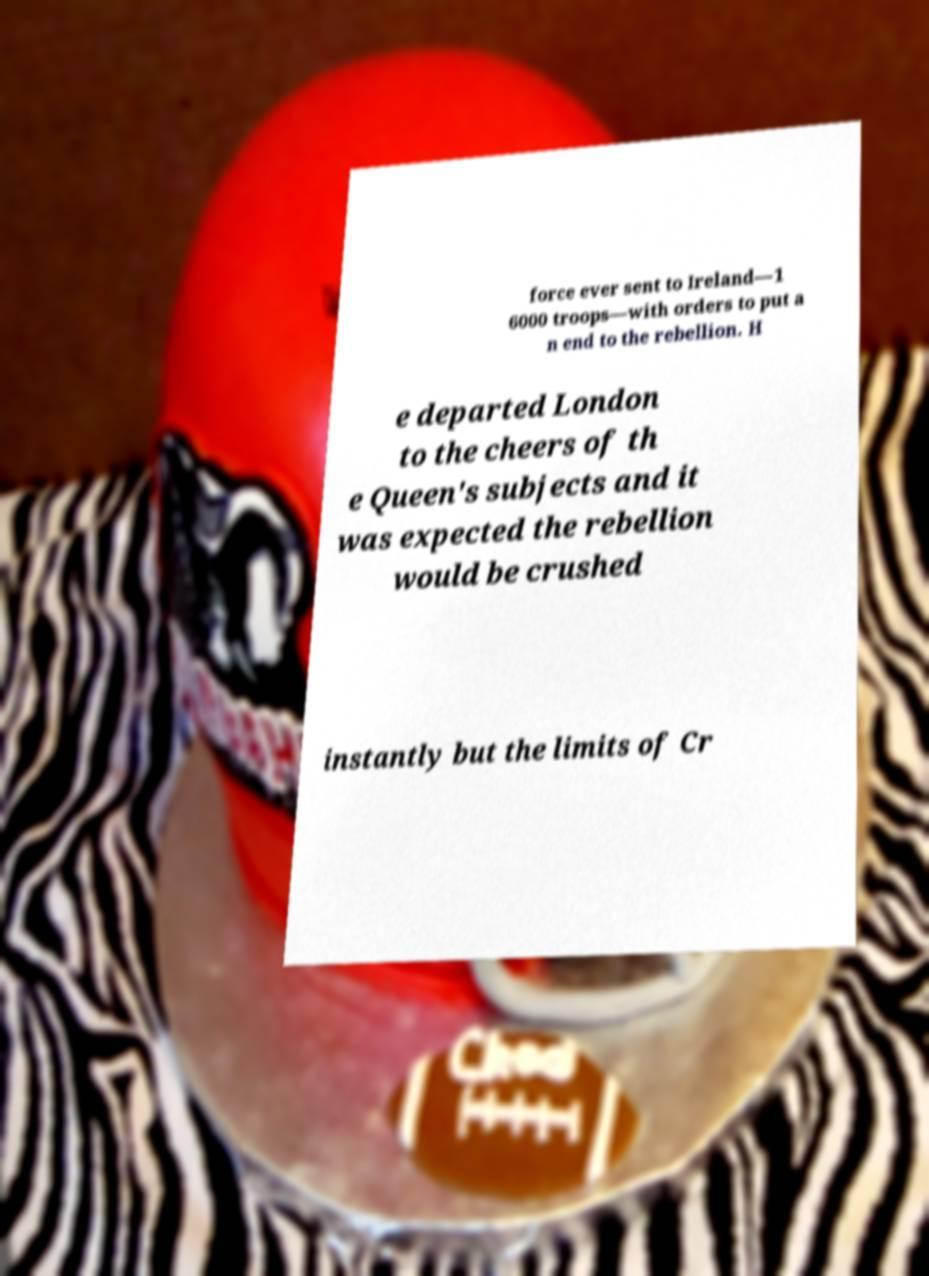Please read and relay the text visible in this image. What does it say? force ever sent to Ireland—1 6000 troops—with orders to put a n end to the rebellion. H e departed London to the cheers of th e Queen's subjects and it was expected the rebellion would be crushed instantly but the limits of Cr 